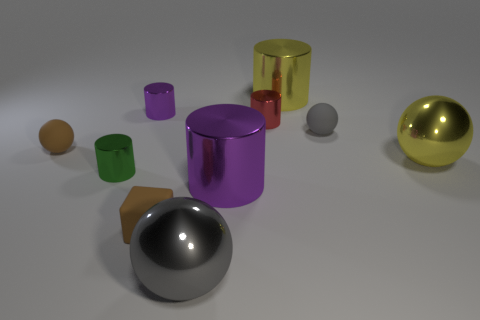Subtract 2 cylinders. How many cylinders are left? 3 Subtract all red shiny cylinders. How many cylinders are left? 4 Subtract all yellow cylinders. How many cylinders are left? 4 Subtract all gray cylinders. Subtract all cyan balls. How many cylinders are left? 5 Subtract all cubes. How many objects are left? 9 Subtract 0 cyan balls. How many objects are left? 10 Subtract all brown matte objects. Subtract all tiny brown balls. How many objects are left? 7 Add 6 yellow metallic balls. How many yellow metallic balls are left? 7 Add 1 big yellow objects. How many big yellow objects exist? 3 